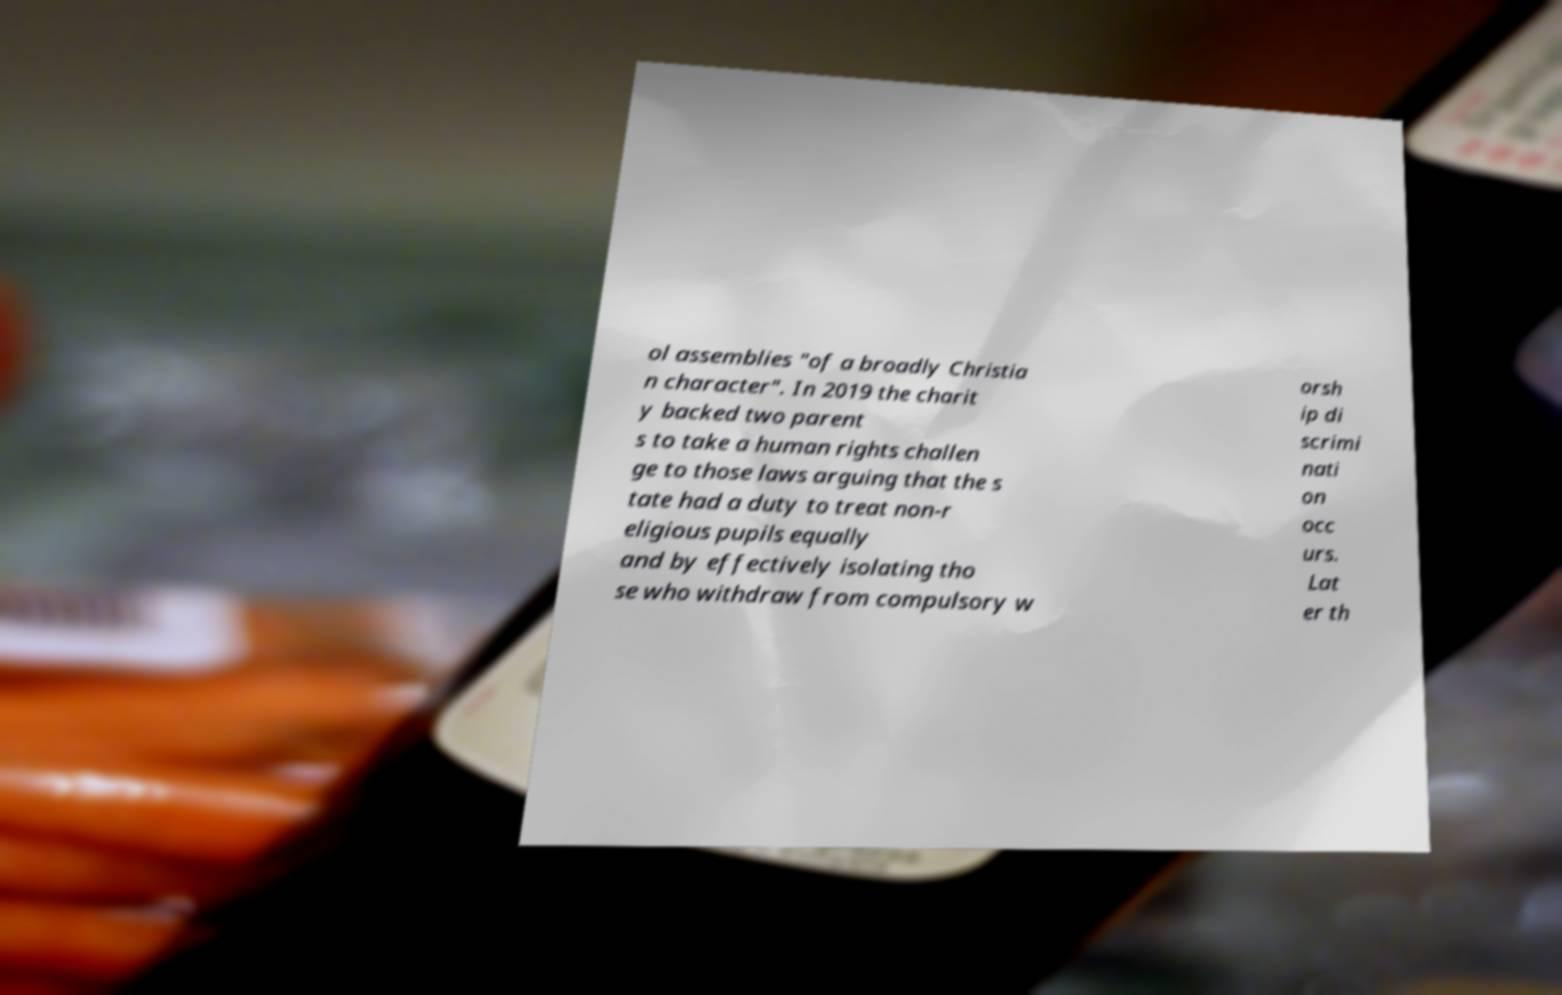Can you accurately transcribe the text from the provided image for me? ol assemblies "of a broadly Christia n character". In 2019 the charit y backed two parent s to take a human rights challen ge to those laws arguing that the s tate had a duty to treat non-r eligious pupils equally and by effectively isolating tho se who withdraw from compulsory w orsh ip di scrimi nati on occ urs. Lat er th 